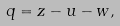<formula> <loc_0><loc_0><loc_500><loc_500>q = z - u - w ,</formula> 